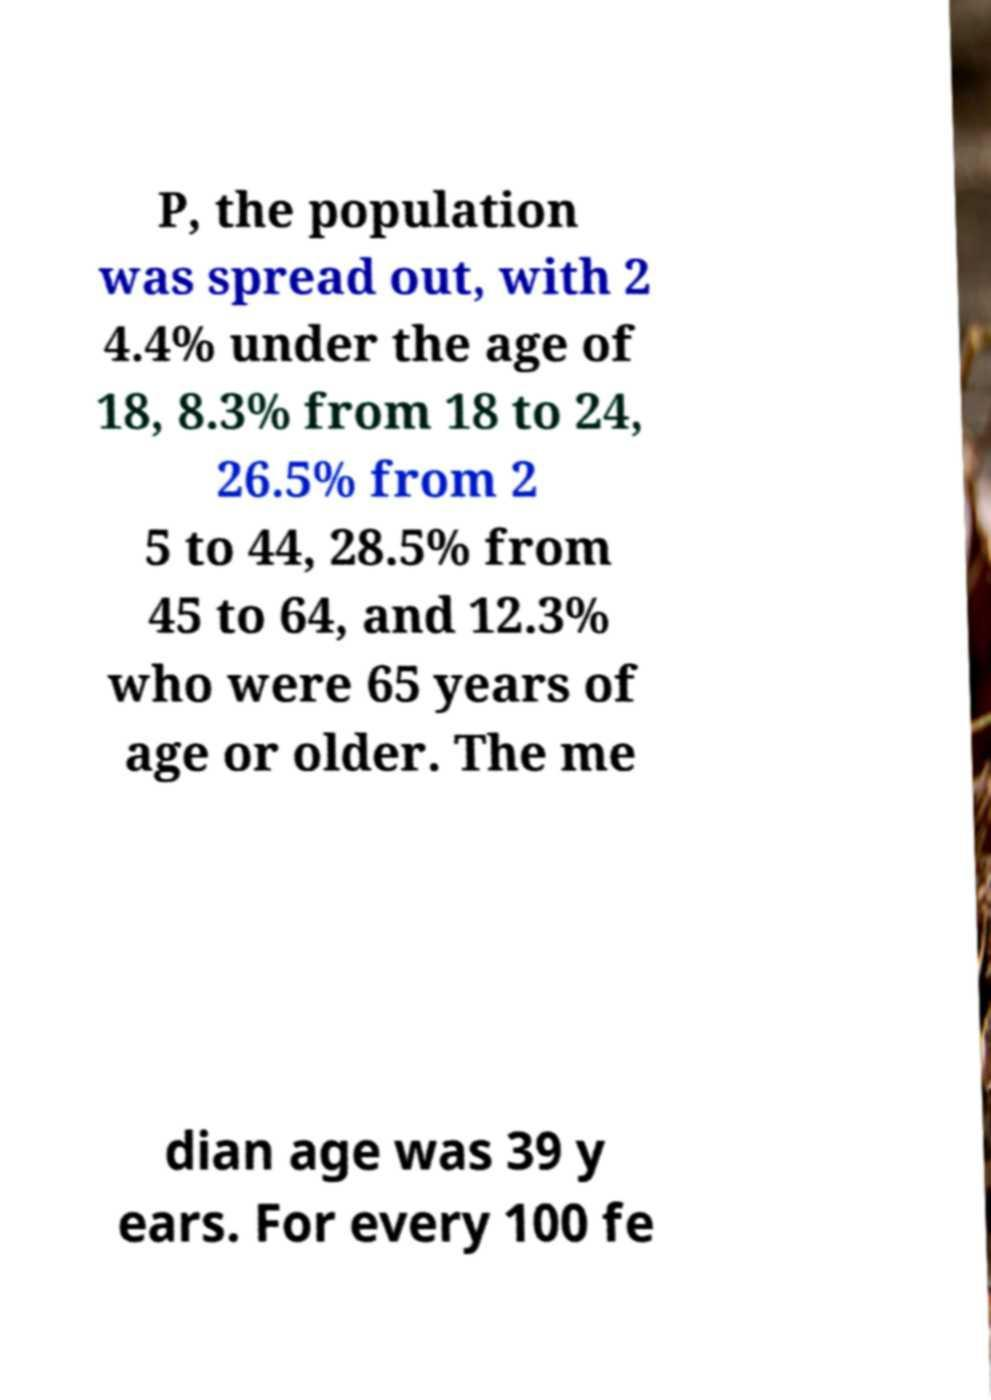Please identify and transcribe the text found in this image. P, the population was spread out, with 2 4.4% under the age of 18, 8.3% from 18 to 24, 26.5% from 2 5 to 44, 28.5% from 45 to 64, and 12.3% who were 65 years of age or older. The me dian age was 39 y ears. For every 100 fe 